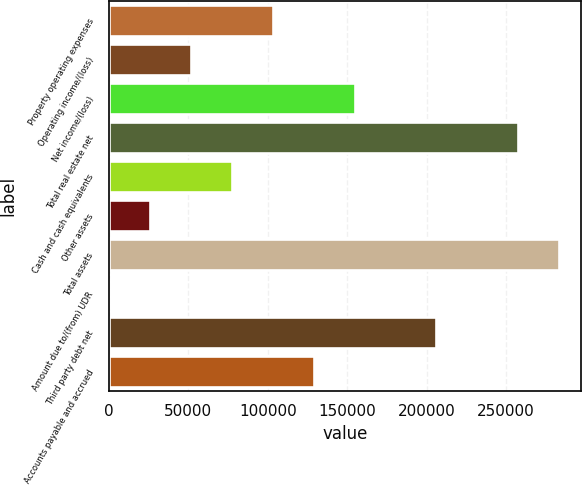<chart> <loc_0><loc_0><loc_500><loc_500><bar_chart><fcel>Property operating expenses<fcel>Operating income/(loss)<fcel>Net income/(loss)<fcel>Total real estate net<fcel>Cash and cash equivalents<fcel>Other assets<fcel>Total assets<fcel>Amount due to/(from) UDR<fcel>Third party debt net<fcel>Accounts payable and accrued<nl><fcel>103191<fcel>51739.4<fcel>154642<fcel>257545<fcel>77465.1<fcel>26013.7<fcel>283271<fcel>288<fcel>206094<fcel>128916<nl></chart> 